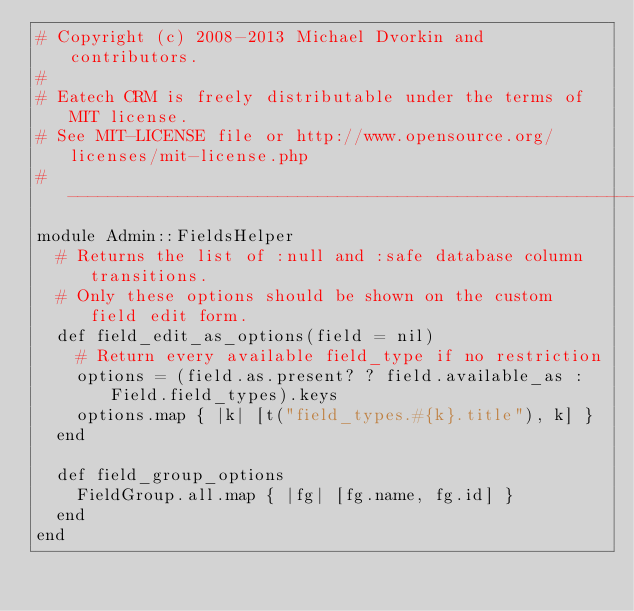<code> <loc_0><loc_0><loc_500><loc_500><_Ruby_># Copyright (c) 2008-2013 Michael Dvorkin and contributors.
#
# Eatech CRM is freely distributable under the terms of MIT license.
# See MIT-LICENSE file or http://www.opensource.org/licenses/mit-license.php
#------------------------------------------------------------------------------
module Admin::FieldsHelper
  # Returns the list of :null and :safe database column transitions.
  # Only these options should be shown on the custom field edit form.
  def field_edit_as_options(field = nil)
    # Return every available field_type if no restriction
    options = (field.as.present? ? field.available_as : Field.field_types).keys
    options.map { |k| [t("field_types.#{k}.title"), k] }
  end

  def field_group_options
    FieldGroup.all.map { |fg| [fg.name, fg.id] }
  end
end
</code> 